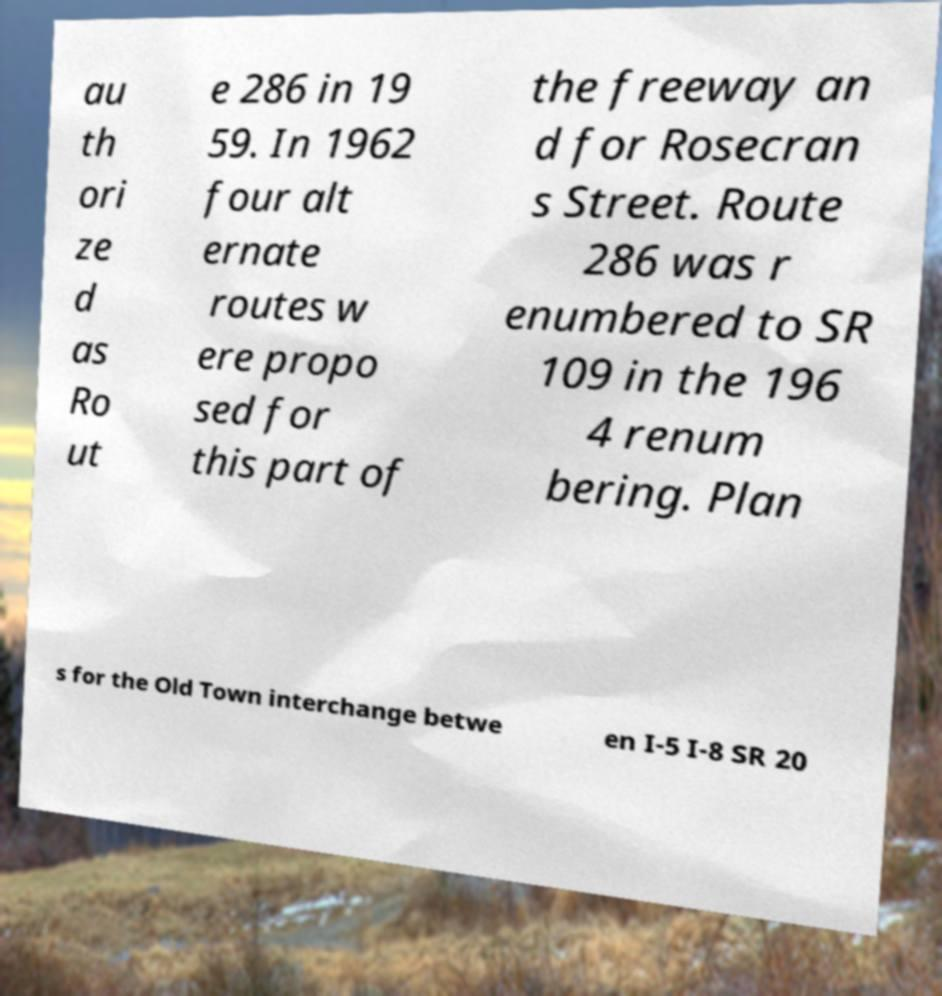I need the written content from this picture converted into text. Can you do that? au th ori ze d as Ro ut e 286 in 19 59. In 1962 four alt ernate routes w ere propo sed for this part of the freeway an d for Rosecran s Street. Route 286 was r enumbered to SR 109 in the 196 4 renum bering. Plan s for the Old Town interchange betwe en I-5 I-8 SR 20 